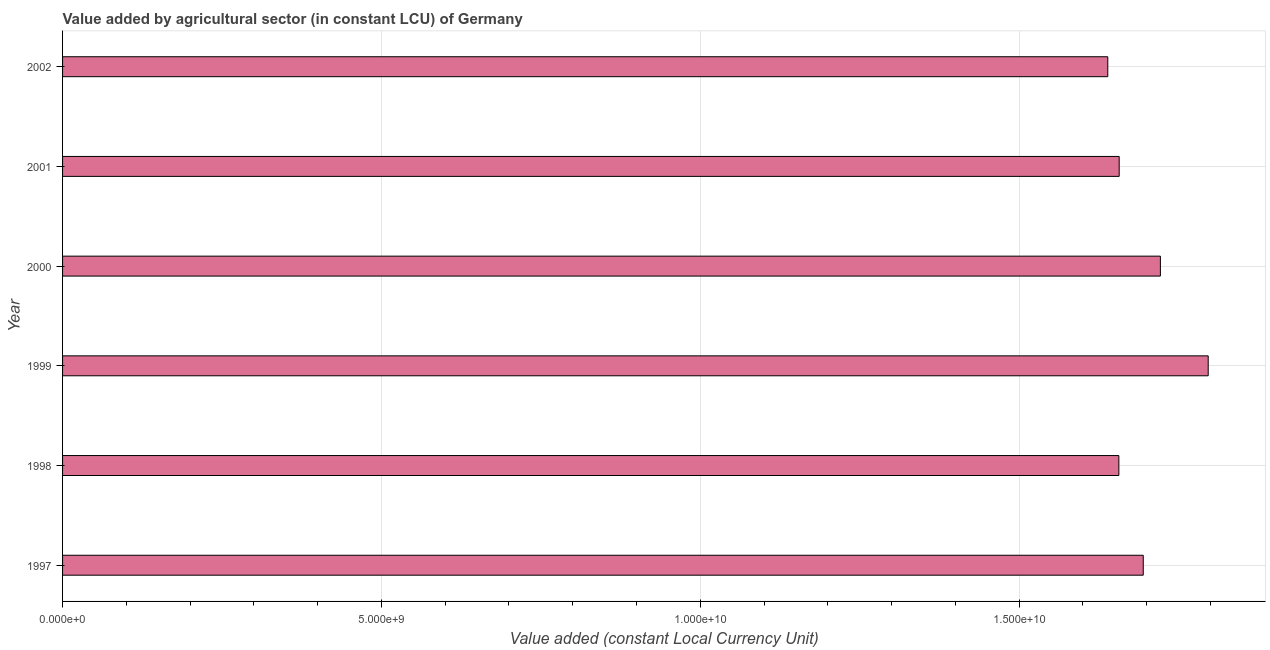What is the title of the graph?
Provide a short and direct response. Value added by agricultural sector (in constant LCU) of Germany. What is the label or title of the X-axis?
Offer a terse response. Value added (constant Local Currency Unit). What is the label or title of the Y-axis?
Provide a short and direct response. Year. What is the value added by agriculture sector in 2000?
Give a very brief answer. 1.72e+1. Across all years, what is the maximum value added by agriculture sector?
Offer a very short reply. 1.80e+1. Across all years, what is the minimum value added by agriculture sector?
Offer a very short reply. 1.64e+1. In which year was the value added by agriculture sector maximum?
Give a very brief answer. 1999. In which year was the value added by agriculture sector minimum?
Give a very brief answer. 2002. What is the sum of the value added by agriculture sector?
Provide a succinct answer. 1.02e+11. What is the difference between the value added by agriculture sector in 1997 and 1999?
Your response must be concise. -1.02e+09. What is the average value added by agriculture sector per year?
Provide a short and direct response. 1.69e+1. What is the median value added by agriculture sector?
Offer a very short reply. 1.68e+1. What is the ratio of the value added by agriculture sector in 1998 to that in 1999?
Your answer should be very brief. 0.92. Is the difference between the value added by agriculture sector in 1998 and 2000 greater than the difference between any two years?
Ensure brevity in your answer.  No. What is the difference between the highest and the second highest value added by agriculture sector?
Give a very brief answer. 7.50e+08. What is the difference between the highest and the lowest value added by agriculture sector?
Your response must be concise. 1.57e+09. In how many years, is the value added by agriculture sector greater than the average value added by agriculture sector taken over all years?
Offer a very short reply. 3. How many years are there in the graph?
Your answer should be very brief. 6. What is the difference between two consecutive major ticks on the X-axis?
Offer a terse response. 5.00e+09. Are the values on the major ticks of X-axis written in scientific E-notation?
Your answer should be very brief. Yes. What is the Value added (constant Local Currency Unit) of 1997?
Ensure brevity in your answer.  1.69e+1. What is the Value added (constant Local Currency Unit) of 1998?
Your answer should be very brief. 1.66e+1. What is the Value added (constant Local Currency Unit) in 1999?
Ensure brevity in your answer.  1.80e+1. What is the Value added (constant Local Currency Unit) in 2000?
Provide a succinct answer. 1.72e+1. What is the Value added (constant Local Currency Unit) of 2001?
Offer a very short reply. 1.66e+1. What is the Value added (constant Local Currency Unit) of 2002?
Give a very brief answer. 1.64e+1. What is the difference between the Value added (constant Local Currency Unit) in 1997 and 1998?
Your answer should be very brief. 3.82e+08. What is the difference between the Value added (constant Local Currency Unit) in 1997 and 1999?
Make the answer very short. -1.02e+09. What is the difference between the Value added (constant Local Currency Unit) in 1997 and 2000?
Offer a terse response. -2.69e+08. What is the difference between the Value added (constant Local Currency Unit) in 1997 and 2001?
Offer a terse response. 3.77e+08. What is the difference between the Value added (constant Local Currency Unit) in 1997 and 2002?
Your response must be concise. 5.56e+08. What is the difference between the Value added (constant Local Currency Unit) in 1998 and 1999?
Ensure brevity in your answer.  -1.40e+09. What is the difference between the Value added (constant Local Currency Unit) in 1998 and 2000?
Offer a very short reply. -6.51e+08. What is the difference between the Value added (constant Local Currency Unit) in 1998 and 2001?
Your answer should be very brief. -5.01e+06. What is the difference between the Value added (constant Local Currency Unit) in 1998 and 2002?
Offer a very short reply. 1.74e+08. What is the difference between the Value added (constant Local Currency Unit) in 1999 and 2000?
Provide a succinct answer. 7.50e+08. What is the difference between the Value added (constant Local Currency Unit) in 1999 and 2001?
Your answer should be very brief. 1.40e+09. What is the difference between the Value added (constant Local Currency Unit) in 1999 and 2002?
Provide a short and direct response. 1.57e+09. What is the difference between the Value added (constant Local Currency Unit) in 2000 and 2001?
Provide a succinct answer. 6.46e+08. What is the difference between the Value added (constant Local Currency Unit) in 2000 and 2002?
Provide a short and direct response. 8.25e+08. What is the difference between the Value added (constant Local Currency Unit) in 2001 and 2002?
Give a very brief answer. 1.79e+08. What is the ratio of the Value added (constant Local Currency Unit) in 1997 to that in 1999?
Offer a terse response. 0.94. What is the ratio of the Value added (constant Local Currency Unit) in 1997 to that in 2000?
Your answer should be very brief. 0.98. What is the ratio of the Value added (constant Local Currency Unit) in 1997 to that in 2002?
Offer a very short reply. 1.03. What is the ratio of the Value added (constant Local Currency Unit) in 1998 to that in 1999?
Give a very brief answer. 0.92. What is the ratio of the Value added (constant Local Currency Unit) in 1998 to that in 2001?
Give a very brief answer. 1. What is the ratio of the Value added (constant Local Currency Unit) in 1998 to that in 2002?
Offer a very short reply. 1.01. What is the ratio of the Value added (constant Local Currency Unit) in 1999 to that in 2000?
Provide a succinct answer. 1.04. What is the ratio of the Value added (constant Local Currency Unit) in 1999 to that in 2001?
Your answer should be very brief. 1.08. What is the ratio of the Value added (constant Local Currency Unit) in 1999 to that in 2002?
Provide a succinct answer. 1.1. What is the ratio of the Value added (constant Local Currency Unit) in 2000 to that in 2001?
Provide a succinct answer. 1.04. What is the ratio of the Value added (constant Local Currency Unit) in 2000 to that in 2002?
Make the answer very short. 1.05. 